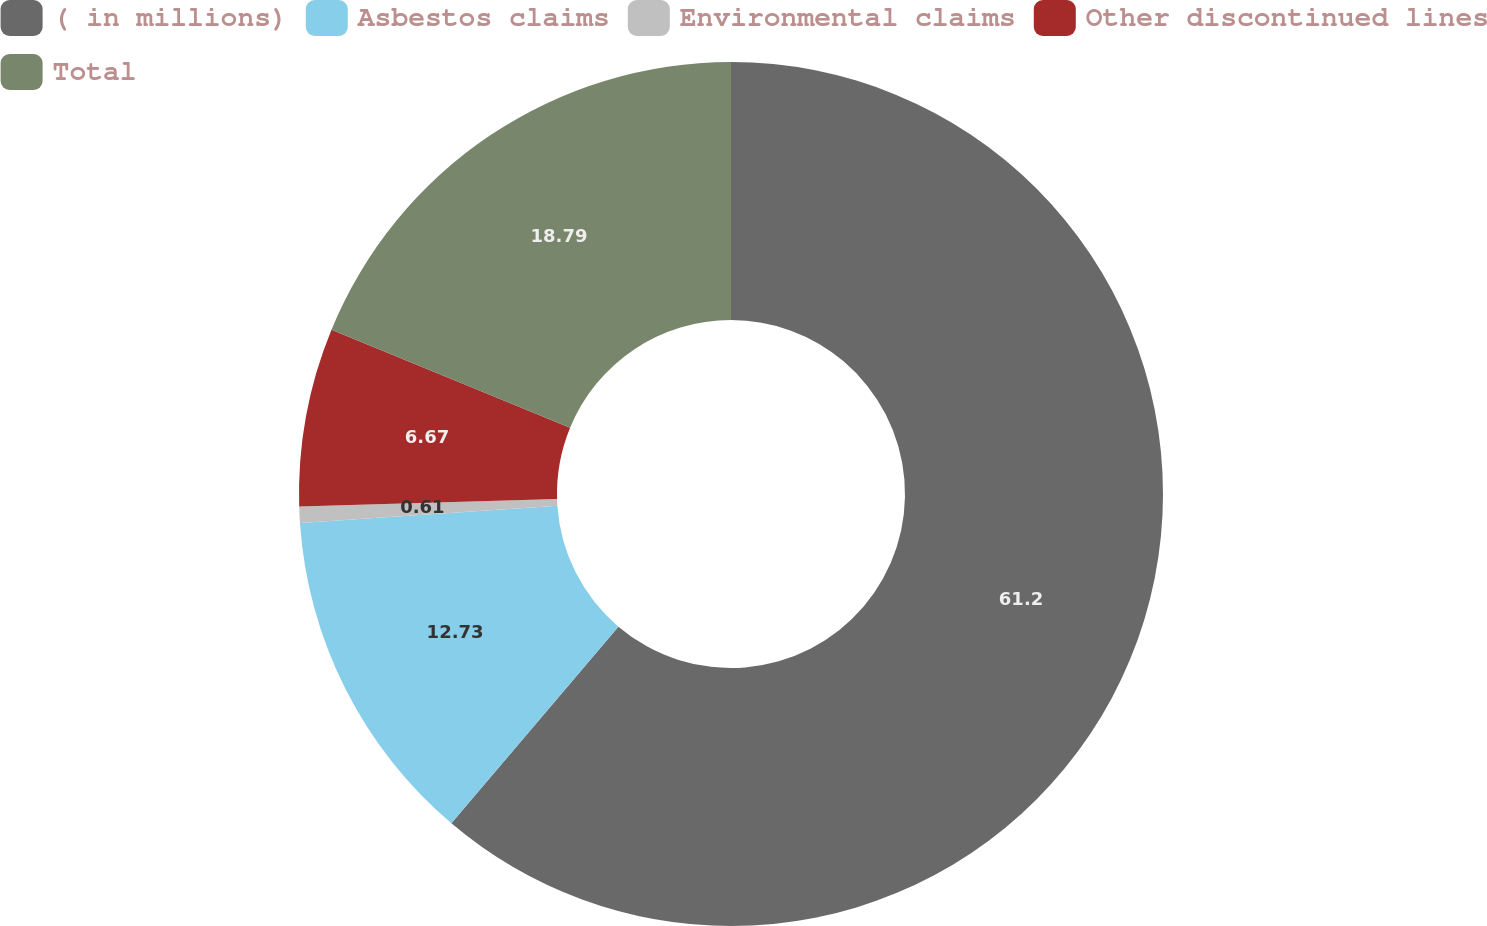<chart> <loc_0><loc_0><loc_500><loc_500><pie_chart><fcel>( in millions)<fcel>Asbestos claims<fcel>Environmental claims<fcel>Other discontinued lines<fcel>Total<nl><fcel>61.21%<fcel>12.73%<fcel>0.61%<fcel>6.67%<fcel>18.79%<nl></chart> 